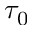Convert formula to latex. <formula><loc_0><loc_0><loc_500><loc_500>\tau _ { 0 }</formula> 